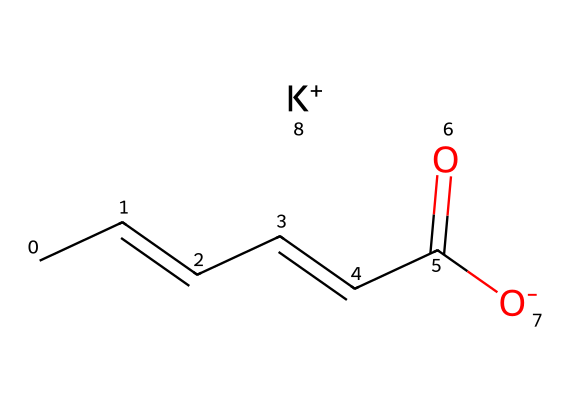What is the molecular formula of potassium sorbate? The SMILES representation can be analyzed to extract the molecular components. Counting the carbon (C), hydrogen (H), oxygen (O), and potassium (K) atoms results in C6H7O2K.
Answer: C6H7O2K How many carbon atoms are present in potassium sorbate? In the SMILES representation, the 'C' symbols indicate carbon atoms. Counting these in the structure shows there are 6 carbon atoms.
Answer: 6 What functional groups are present in this chemical? The structure has a carboxylate group (-COO-) represented by the part "C(=O)[O-]", indicating a carboxylic acid derivative and a double bond between carbon atoms, suggesting an alkene.
Answer: carboxylate, alkene What is the role of potassium in potassium sorbate? Potassium acts as a counterion to the carboxylate group, stabilizing the structure and enhancing solubility, which is crucial for its function as a preservative.
Answer: counterion How many double bonds are there in this molecule? By examining the structure, we identify that there are two double bonds between carbon atoms, which indicates that it is an unsaturated compound.
Answer: 2 Which part of the structure indicates its role as a preservative? The carboxylate group represents the active part of the molecule that interacts with microbial enzymes, leading to its preservative action.
Answer: carboxylate group 